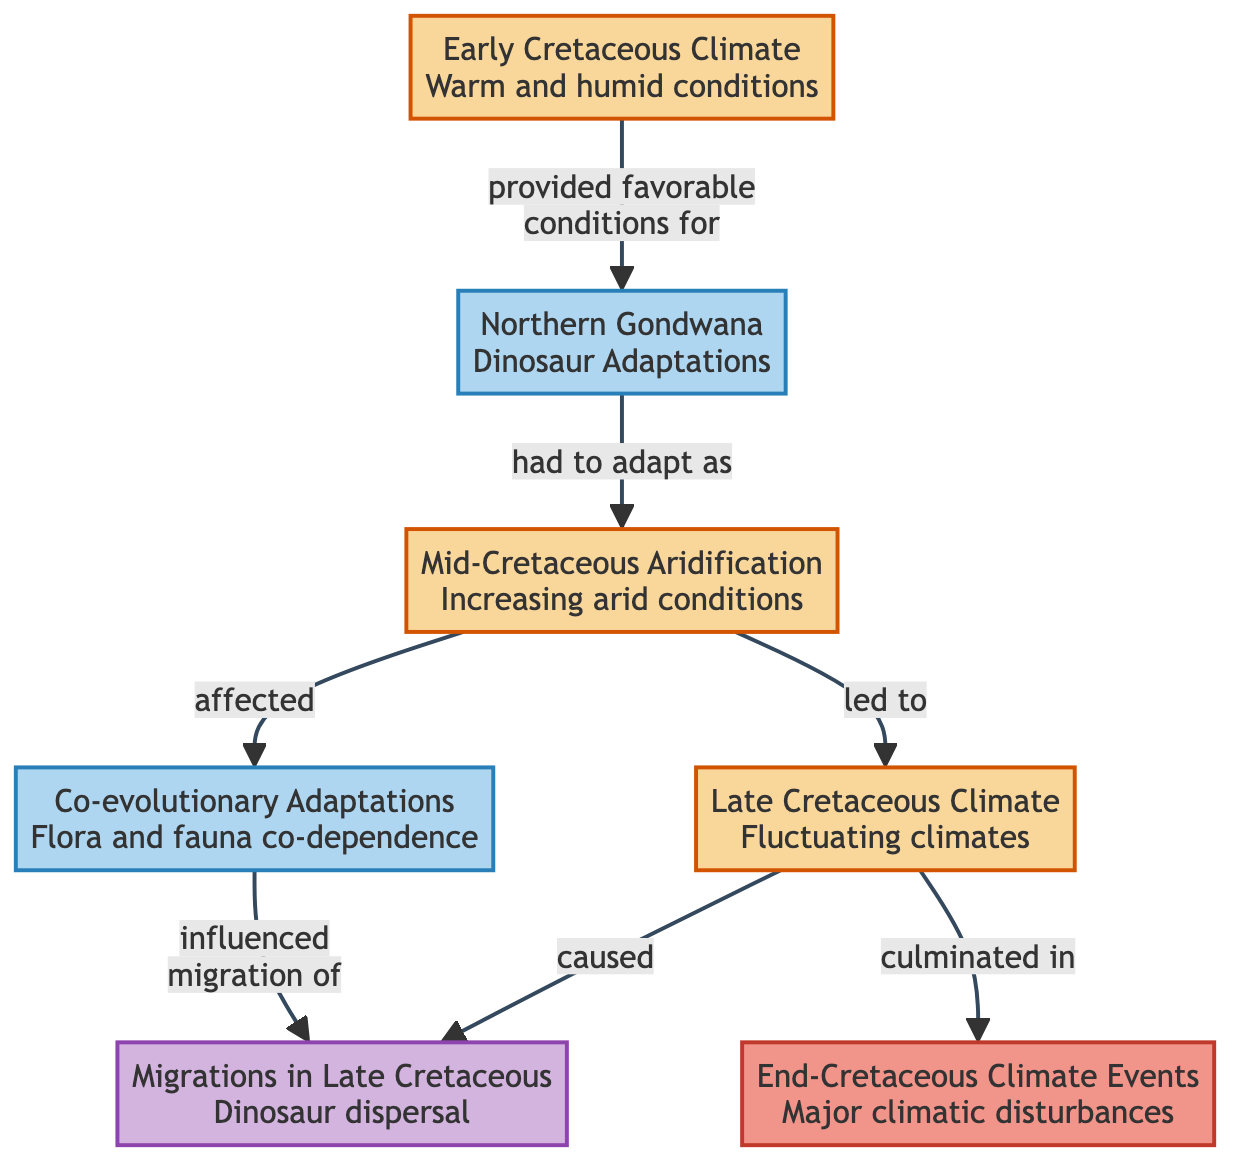What does the "Early Cretaceous Climate" block describe? The "Early Cretaceous Climate" block describes warm and humid conditions characterized by high global temperatures and lush coastal habitats.
Answer: warm and humid conditions Which block follows "Northern Gondwana"? "Northern Gondwana" is followed by "Mid-Cretaceous Aridification," which indicates a shift to increasing arid conditions.
Answer: Mid-Cretaceous Aridification How many connections are there in the diagram? There are seven connections that illustrate the relationships between different blocks in the diagram.
Answer: 7 What adaptations did dinosaurs have in "Northern Gondwana"? Dinosaurs in "Northern Gondwana" adapted to the dense forests and riverine ecosystems highlighted in that block.
Answer: dense forests and riverine ecosystems What did the "Mid-Cretaceous Aridification" lead to? The "Mid-Cretaceous Aridification" block led to "Late Cretaceous Climate," indicating the shift to fluctuating climates.
Answer: Late Cretaceous Climate What major climatic events culminated in the "End-Cretaceous Climate Events"? The "Late Cretaceous Climate" experienced major climatic disturbances due to volcanic activity and asteroid impacts, which culminated in the "End-Cretaceous Climate Events."
Answer: volcanic activity and asteroid impacts How did "Co-evolutionary Adaptations" affect dinosaur migrations? "Co-evolutionary Adaptations" influenced the migration of dinosaurs due to the dependence of herbivorous dinosaurs on specific plant evolutions for their diets, as shown in the diagram's connections.
Answer: influenced the migration of What is the relationship between "Late Cretaceous Climate" and "Migrations in Late Cretaceous"? The relationship indicates that the changing climates during the "Late Cretaceous Climate" caused migrations among dinosaur populations, highlighting the impact of environmental changes on dinosaur dispersal.
Answer: caused 